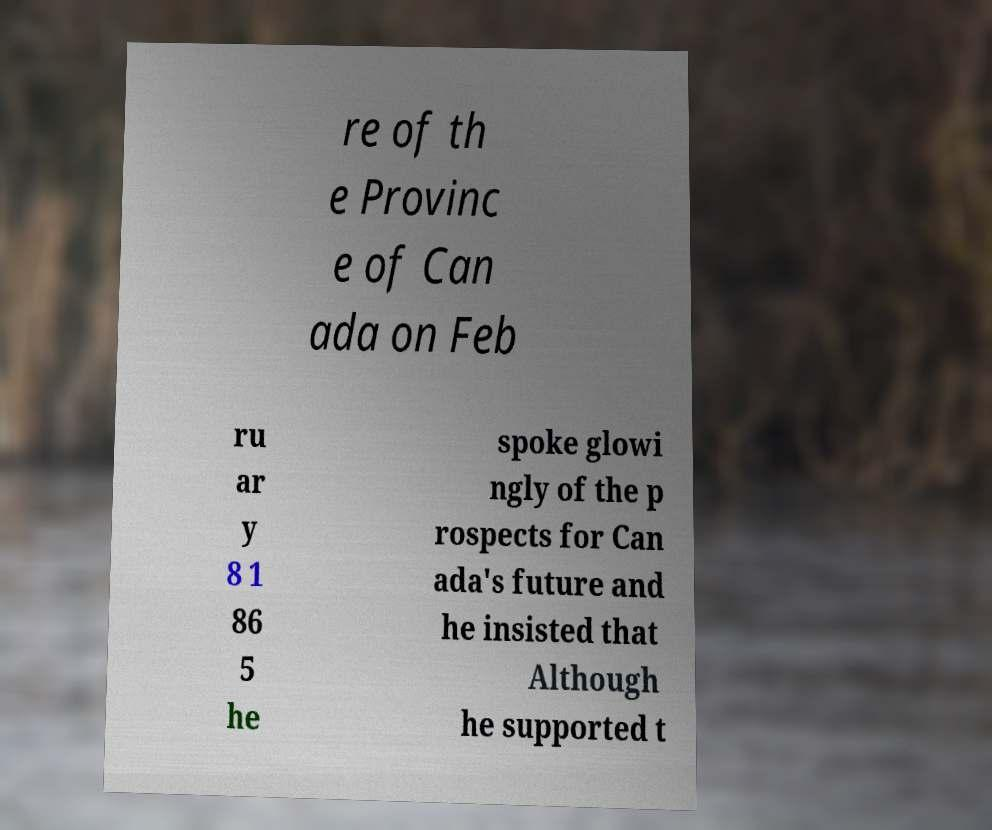Can you read and provide the text displayed in the image?This photo seems to have some interesting text. Can you extract and type it out for me? re of th e Provinc e of Can ada on Feb ru ar y 8 1 86 5 he spoke glowi ngly of the p rospects for Can ada's future and he insisted that Although he supported t 